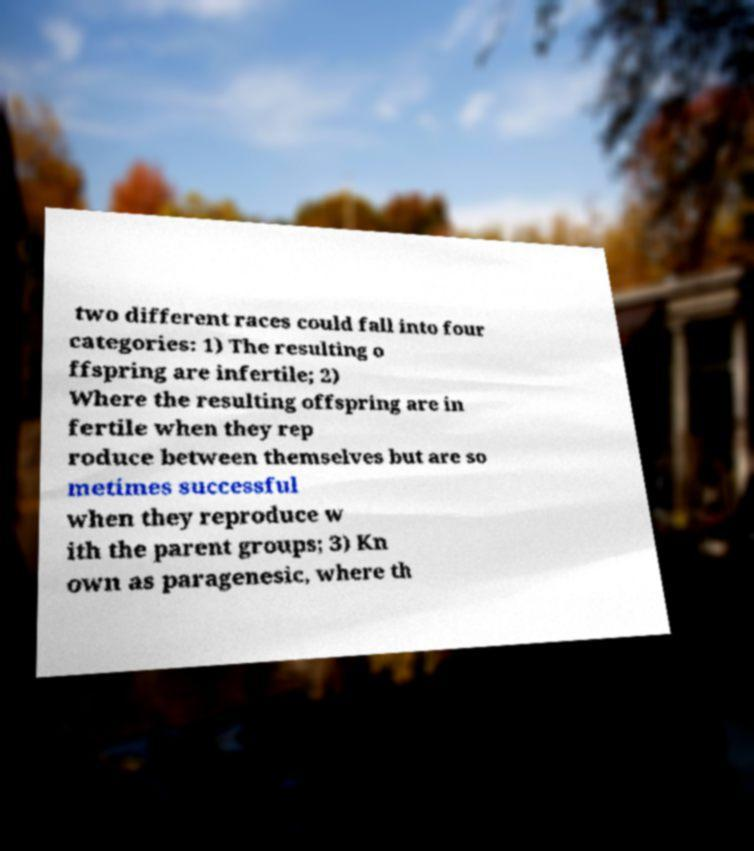There's text embedded in this image that I need extracted. Can you transcribe it verbatim? two different races could fall into four categories: 1) The resulting o ffspring are infertile; 2) Where the resulting offspring are in fertile when they rep roduce between themselves but are so metimes successful when they reproduce w ith the parent groups; 3) Kn own as paragenesic, where th 